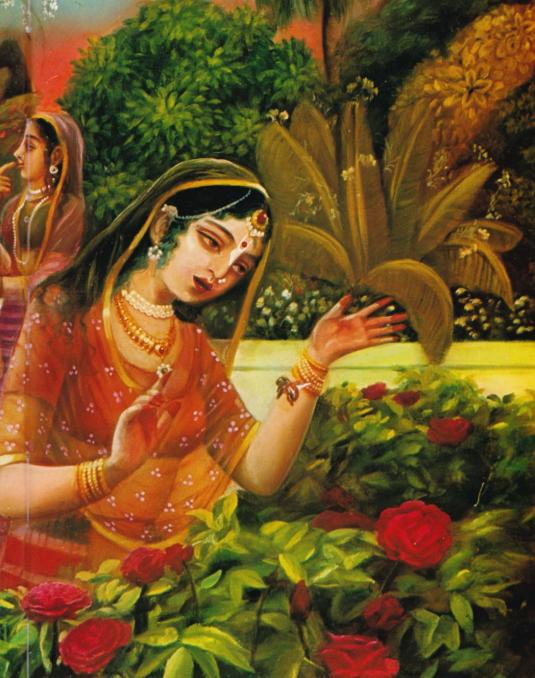How does the presence of the second woman in the background contribute to the overall interpretation of the scene? The presence of the second woman in the background adds a layer of complexity and social context to the scene. It suggests a shared experience or a moment of companionship. This could imply that the primary woman is part of a larger narrative involving other characters, potentially indicating a ritual, celebration, or a moment of collective appreciation. The secondary figure enhances the depth of the story depicted in the painting, highlighting themes of community, relationship, and shared moments of beauty or devotion. 